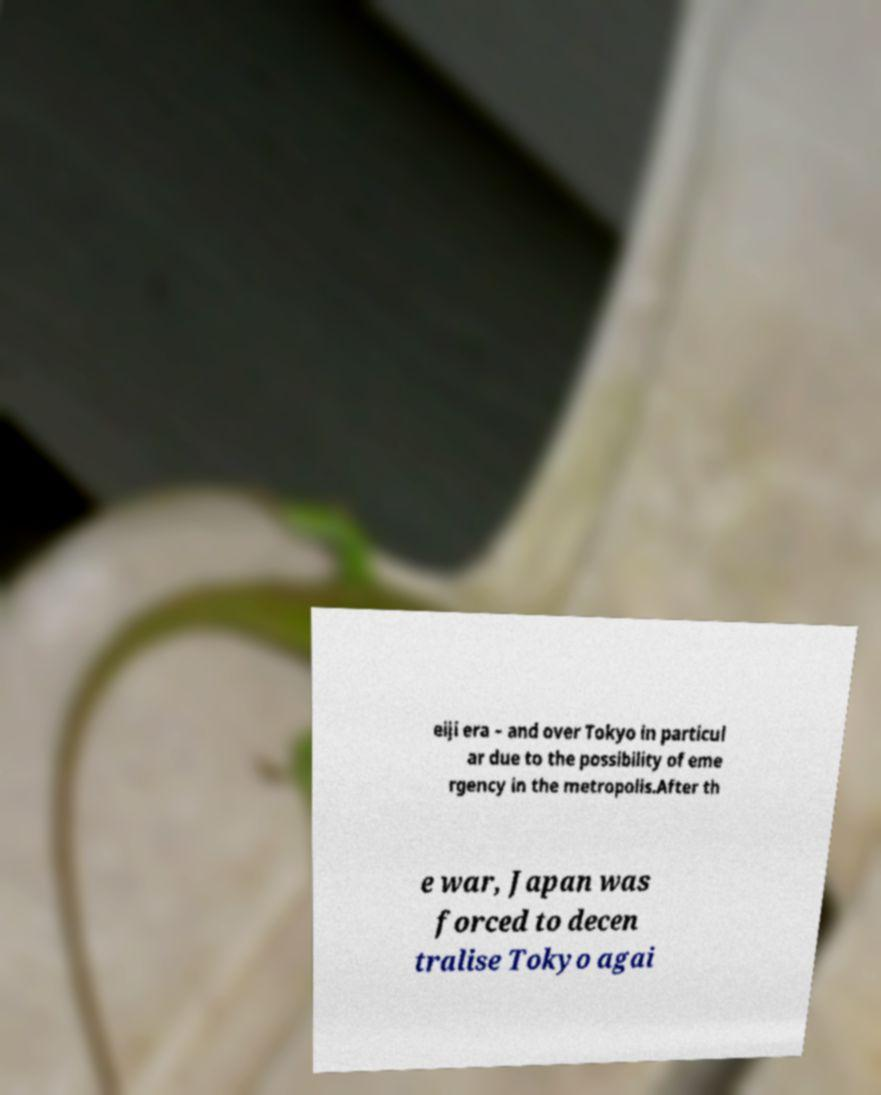Could you assist in decoding the text presented in this image and type it out clearly? eiji era – and over Tokyo in particul ar due to the possibility of eme rgency in the metropolis.After th e war, Japan was forced to decen tralise Tokyo agai 